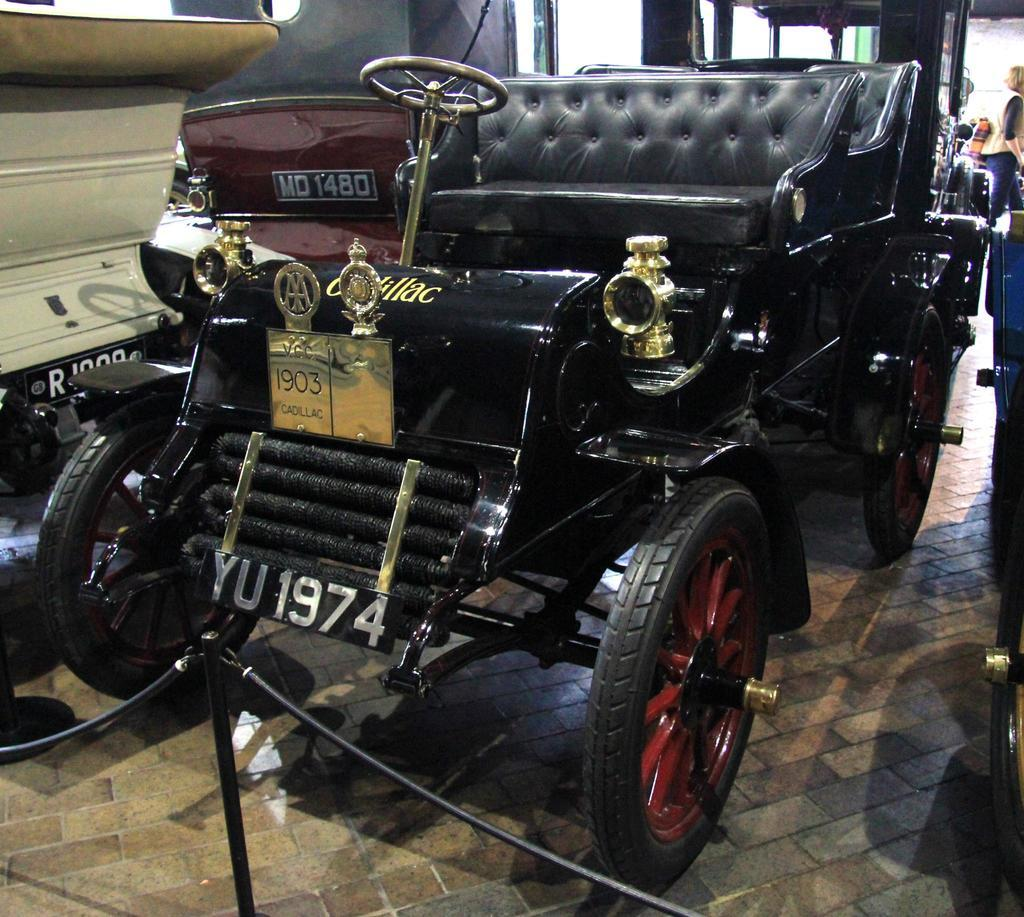What color is the main vehicle in the image? The main vehicle in the image is black-colored. Are there any other vehicles in the image? Yes, there are other vehicles beside the black-colored vehicle. Can you describe the person in the image? There is a person standing in the right top corner of the image. What type of toy can be seen in the image? There is no toy present in the image. Is there a loaf of bread visible in the image? There is no loaf of bread present in the image. 